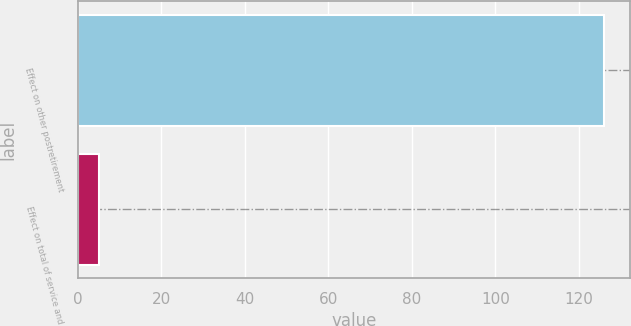Convert chart. <chart><loc_0><loc_0><loc_500><loc_500><bar_chart><fcel>Effect on other postretirement<fcel>Effect on total of service and<nl><fcel>126<fcel>5<nl></chart> 